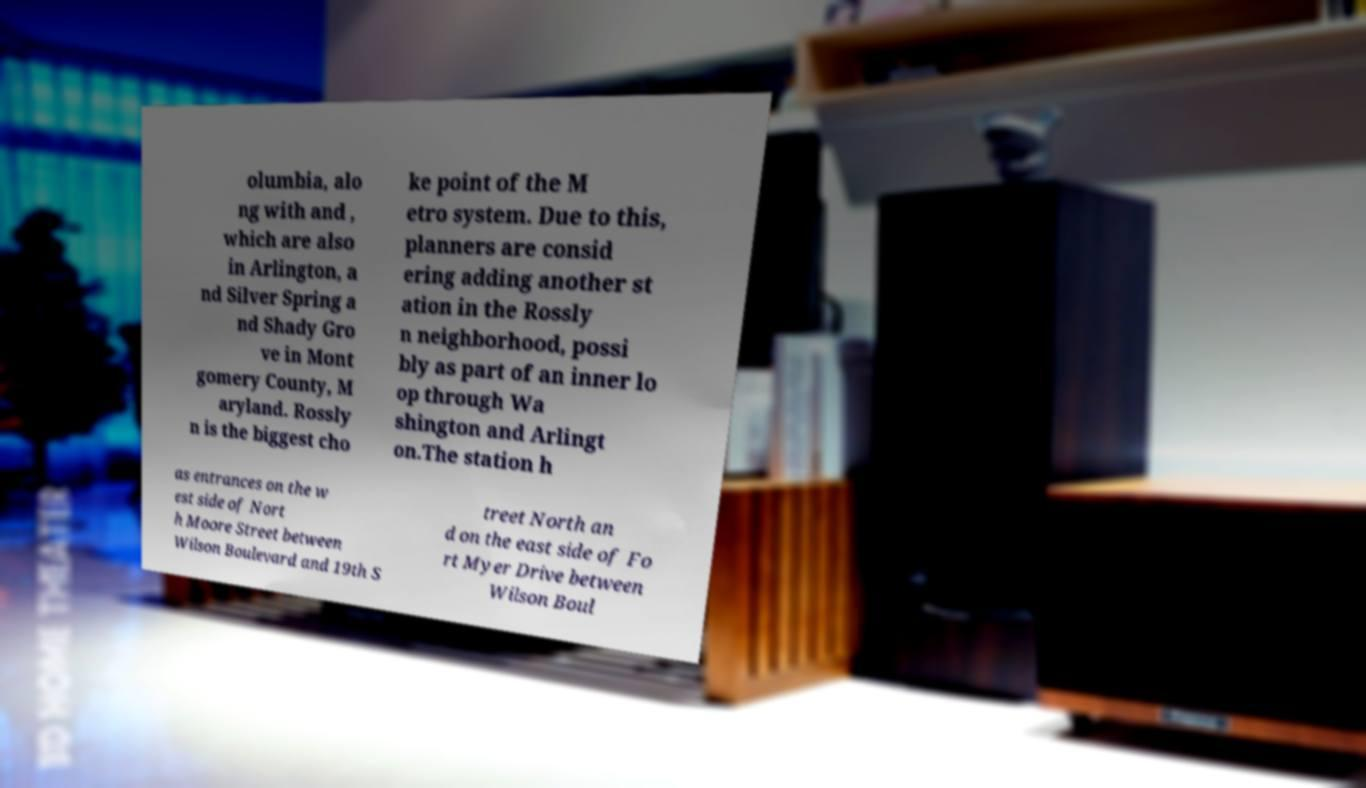Can you accurately transcribe the text from the provided image for me? olumbia, alo ng with and , which are also in Arlington, a nd Silver Spring a nd Shady Gro ve in Mont gomery County, M aryland. Rossly n is the biggest cho ke point of the M etro system. Due to this, planners are consid ering adding another st ation in the Rossly n neighborhood, possi bly as part of an inner lo op through Wa shington and Arlingt on.The station h as entrances on the w est side of Nort h Moore Street between Wilson Boulevard and 19th S treet North an d on the east side of Fo rt Myer Drive between Wilson Boul 